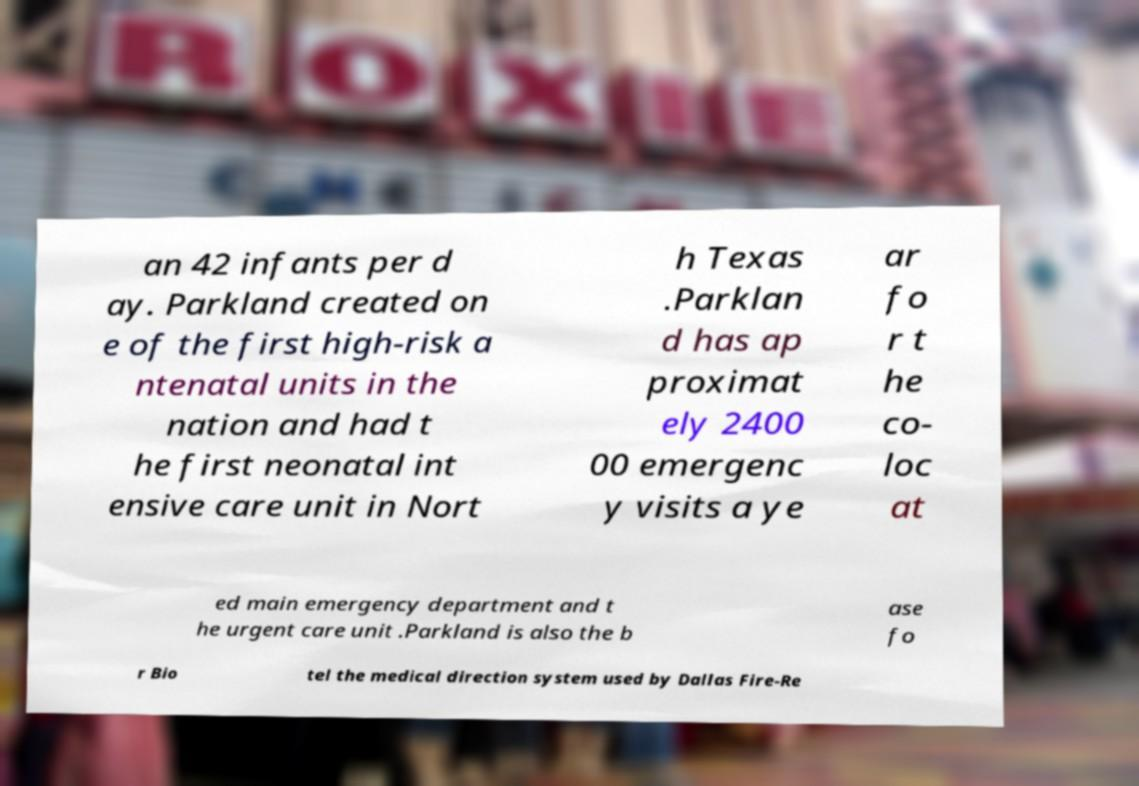Could you assist in decoding the text presented in this image and type it out clearly? an 42 infants per d ay. Parkland created on e of the first high-risk a ntenatal units in the nation and had t he first neonatal int ensive care unit in Nort h Texas .Parklan d has ap proximat ely 2400 00 emergenc y visits a ye ar fo r t he co- loc at ed main emergency department and t he urgent care unit .Parkland is also the b ase fo r Bio tel the medical direction system used by Dallas Fire-Re 